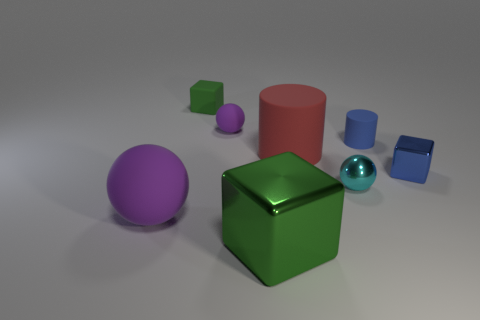There is a purple ball behind the cyan ball; is its size the same as the small blue metal block?
Offer a very short reply. Yes. How big is the purple rubber sphere that is behind the metal cube behind the cyan shiny thing?
Provide a short and direct response. Small. Are the large cylinder and the ball that is in front of the cyan metal sphere made of the same material?
Make the answer very short. Yes. Are there fewer big purple matte things to the right of the large green block than rubber cylinders behind the small purple matte thing?
Keep it short and to the point. No. What is the color of the other tiny cylinder that is the same material as the red cylinder?
Your response must be concise. Blue. There is a green block that is behind the tiny shiny cube; is there a rubber ball behind it?
Offer a terse response. No. What color is the other metal thing that is the same size as the red object?
Offer a very short reply. Green. What number of objects are big yellow blocks or big things?
Give a very brief answer. 3. There is a green object that is on the left side of the green block right of the block that is behind the blue rubber cylinder; how big is it?
Offer a very short reply. Small. How many large objects have the same color as the big shiny block?
Ensure brevity in your answer.  0. 